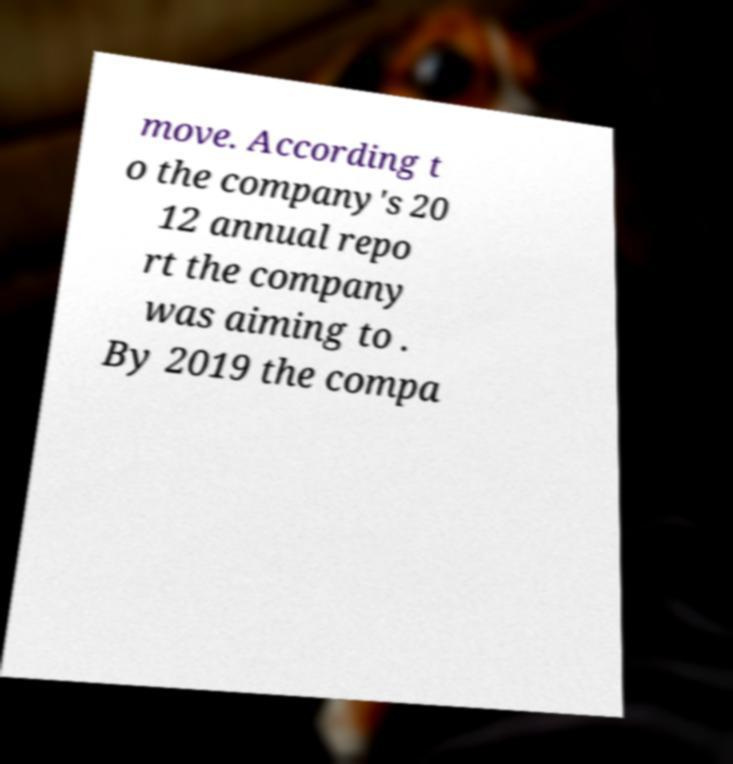What messages or text are displayed in this image? I need them in a readable, typed format. move. According t o the company's 20 12 annual repo rt the company was aiming to . By 2019 the compa 